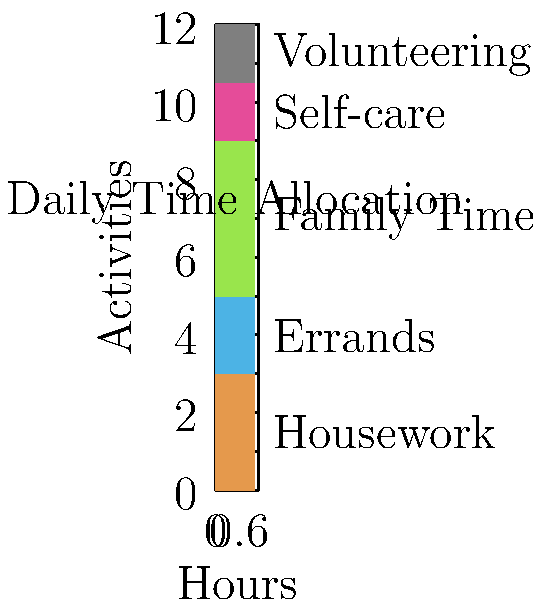As a military spouse who excels in time management, you've tracked your daily activities using a stacked bar graph. If you wanted to increase your volunteering time by 1 hour while maintaining the same total hours, which single activity could you reduce to accommodate this change? To answer this question, we need to analyze the time spent on each activity as shown in the stacked bar graph:

1. Housework: 3 hours
2. Errands: 2 hours
3. Family Time: 4 hours
4. Self-care: 1.5 hours
5. Volunteering: 1.5 hours

We need to find a single activity that, if reduced by 1 hour, would allow us to increase volunteering time by 1 hour without changing the total time.

The only activity that currently takes more than 1 hour and could be reduced by a full hour is Family Time (4 hours). All other activities either take less than 2 hours (Errands, Self-care, Volunteering) or would be too disruptive to reduce by a full hour (Housework).

By reducing Family Time from 4 hours to 3 hours, we can increase Volunteering from 1.5 hours to 2.5 hours, maintaining the same total time while achieving the desired increase in volunteering.
Answer: Family Time 